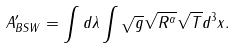<formula> <loc_0><loc_0><loc_500><loc_500>A ^ { \prime } _ { B S W } = \int d \lambda \int \sqrt { g } \sqrt { R ^ { \alpha } } \sqrt { T } d ^ { 3 } x .</formula> 